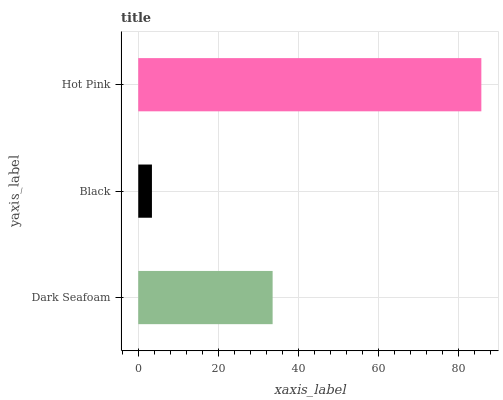Is Black the minimum?
Answer yes or no. Yes. Is Hot Pink the maximum?
Answer yes or no. Yes. Is Hot Pink the minimum?
Answer yes or no. No. Is Black the maximum?
Answer yes or no. No. Is Hot Pink greater than Black?
Answer yes or no. Yes. Is Black less than Hot Pink?
Answer yes or no. Yes. Is Black greater than Hot Pink?
Answer yes or no. No. Is Hot Pink less than Black?
Answer yes or no. No. Is Dark Seafoam the high median?
Answer yes or no. Yes. Is Dark Seafoam the low median?
Answer yes or no. Yes. Is Black the high median?
Answer yes or no. No. Is Black the low median?
Answer yes or no. No. 